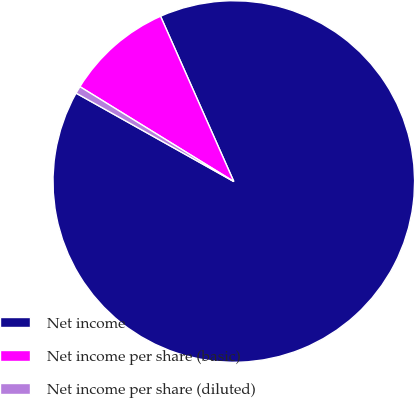Convert chart to OTSL. <chart><loc_0><loc_0><loc_500><loc_500><pie_chart><fcel>Net income<fcel>Net income per share (basic)<fcel>Net income per share (diluted)<nl><fcel>89.77%<fcel>9.57%<fcel>0.66%<nl></chart> 